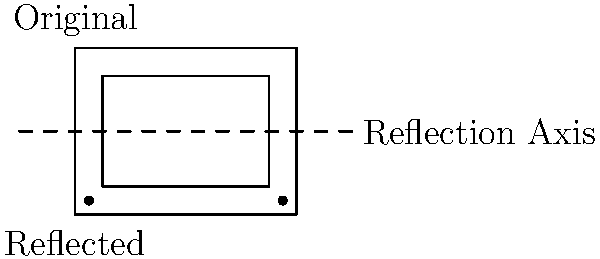In the golden age of television, classic TV set designs were iconic. The diagram shows a simplified representation of a vintage TV set and its reflection across the x-axis. If the original TV set has dimensions of 4 units width and 3 units height, what are the coordinates of the bottom-right corner of the reflected TV set? Let's approach this step-by-step:

1) First, we need to identify the coordinates of the original TV set. Given the dimensions:
   - Width: 4 units
   - Height: 3 units
   
2) If we center the TV set on the origin, the coordinates of its corners would be:
   - Top-left: (-2, 1.5)
   - Top-right: (2, 1.5)
   - Bottom-left: (-2, -1.5)
   - Bottom-right: (2, -1.5)

3) The reflection is across the x-axis, which means:
   - The x-coordinates will remain the same
   - The y-coordinates will change sign

4) For the bottom-right corner:
   - Original coordinates: (2, -1.5)
   - After reflection: (2, 1.5)

Therefore, the coordinates of the bottom-right corner of the reflected TV set are (2, 1.5).
Answer: (2, 1.5) 